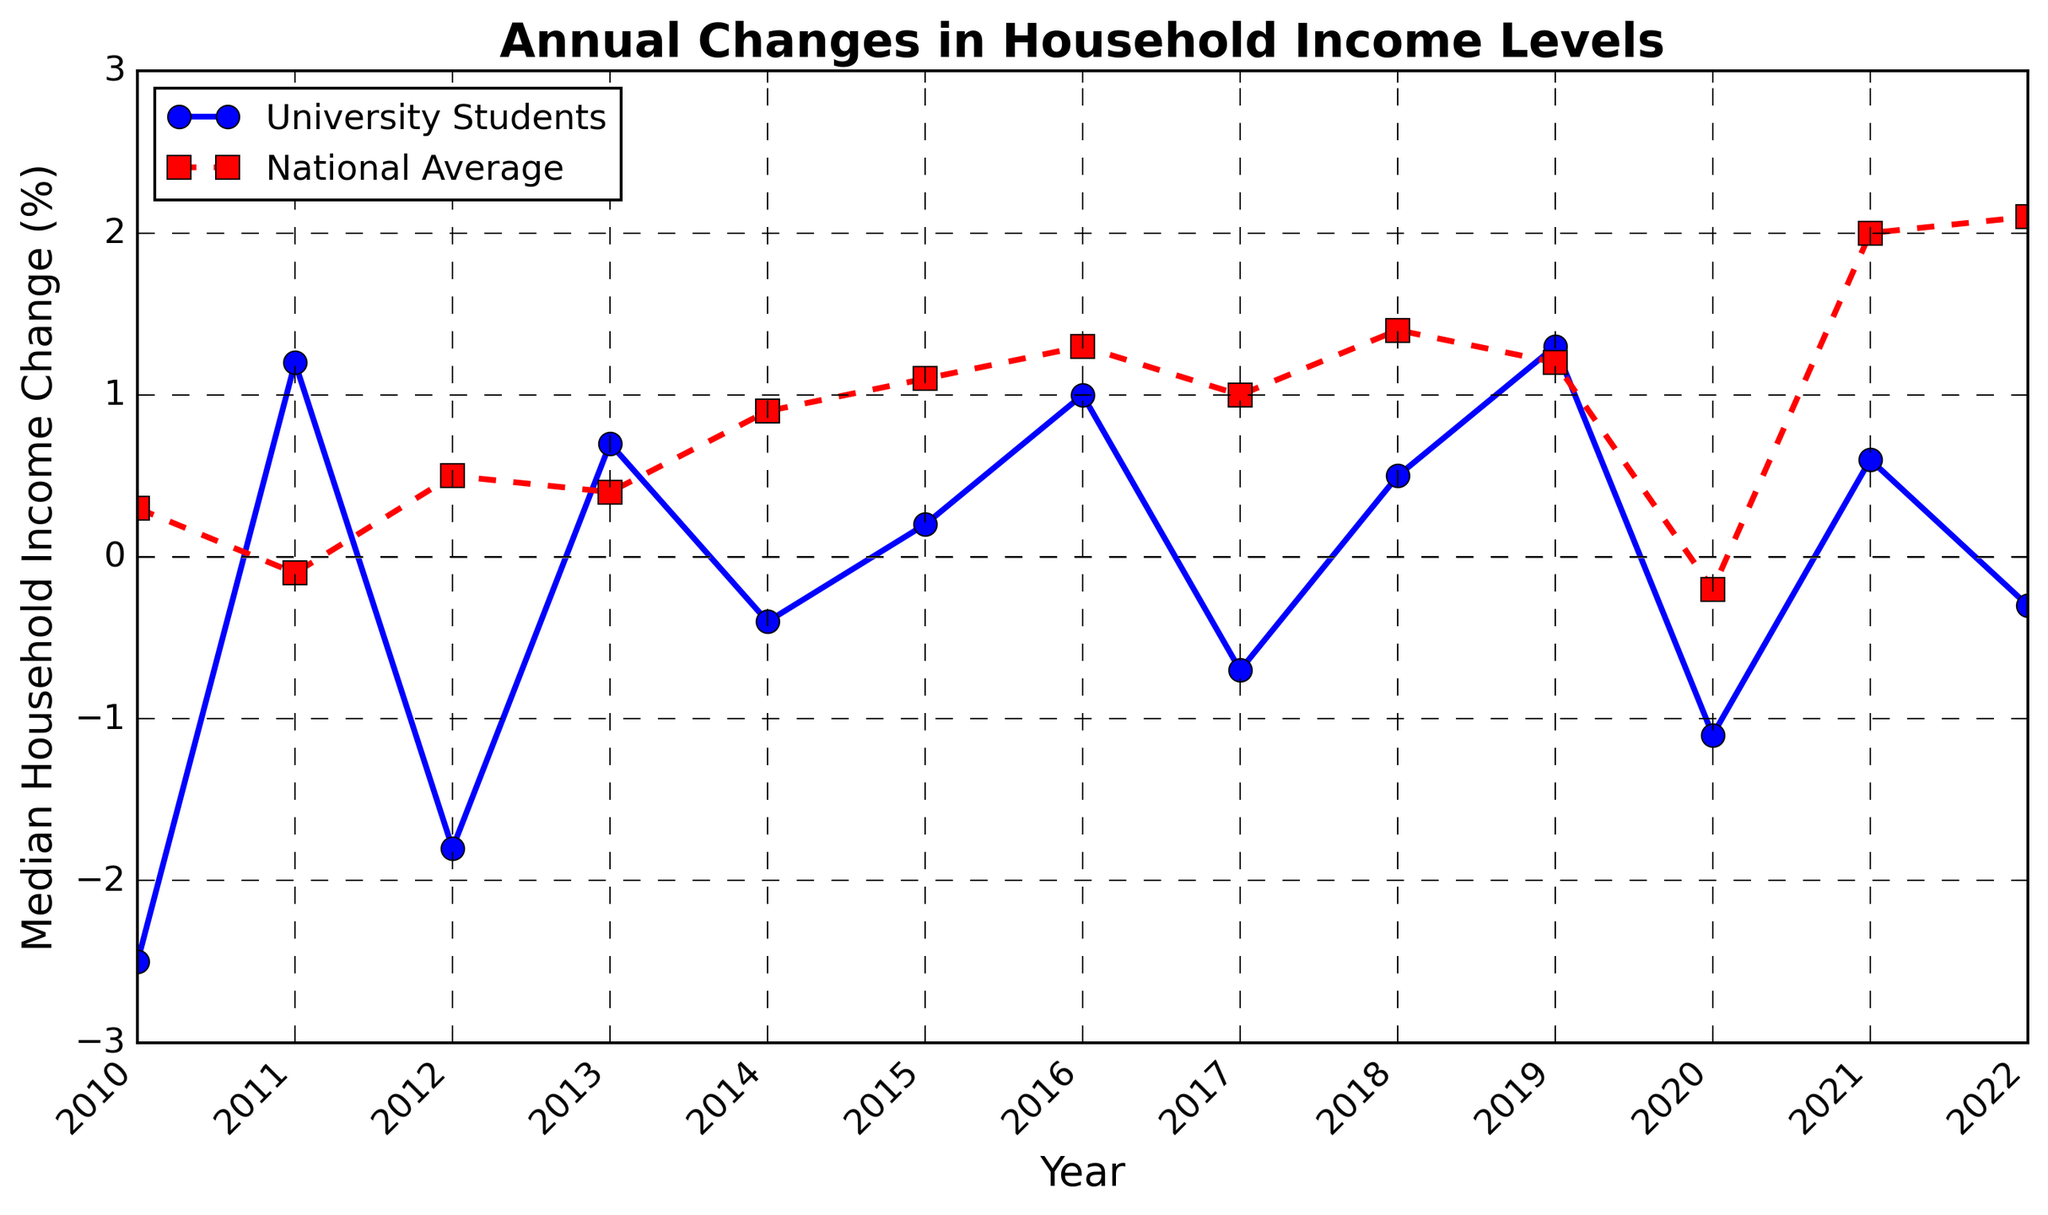What year did the median household income for university students and the national average both experience negative changes? To find the year when both series had negative changes, look for points where both lines are below the y-axis. In 2020, both university students (-1.1) and the national average (-0.2) have negative values.
Answer: 2020 In which year did university students' median household income change the most positively? Check the university students' line for the year with the highest peak above zero. In 2019, the change was 1.3, which is the highest positive change for them.
Answer: 2019 How do the changes in household income for university students in 2022 compare to the national average? Compare the points at 2022 for both lines. University students had a change of -0.3, while the national average had a change of 2.1.
Answer: Students had a negative change, and the national average had a positive change What is the average annual change in median household income for university students from 2010 to 2012? Calculate the average by summing the changes for 2010 (-2.5), 2011 (1.2), and 2012 (-1.8), then divide by 3. (-2.5 + 1.2 - 1.8)/3 = -1.03.
Answer: -1.03 Was there any year where the median household income change for university students and the national average was equal? Scan the figure for years when both lines touch or have the same data points. There is no such year where both have the same change.
Answer: No Which year had the smallest difference between university students' median income change and the national average? Find the year where the gap between the two lines is the shortest by visually comparing. In 2013, the difference is smallest: university students (0.7) and national average (0.4) make a difference of 0.3.
Answer: 2013 How many times did the median household income change for university students fall below zero between 2010 and 2022? Count the years where the university students' line is below the y-axis. It falls below zero in 2010, 2012, 2014, 2017, 2020, and 2022, totaling 6 times.
Answer: 6 In which timeframe did the national average experience a consistent increase? Look for consecutive years where the national average line increases continuously. Between 2014 and 2022, the national average increases without a decrease.
Answer: 2014-2022 